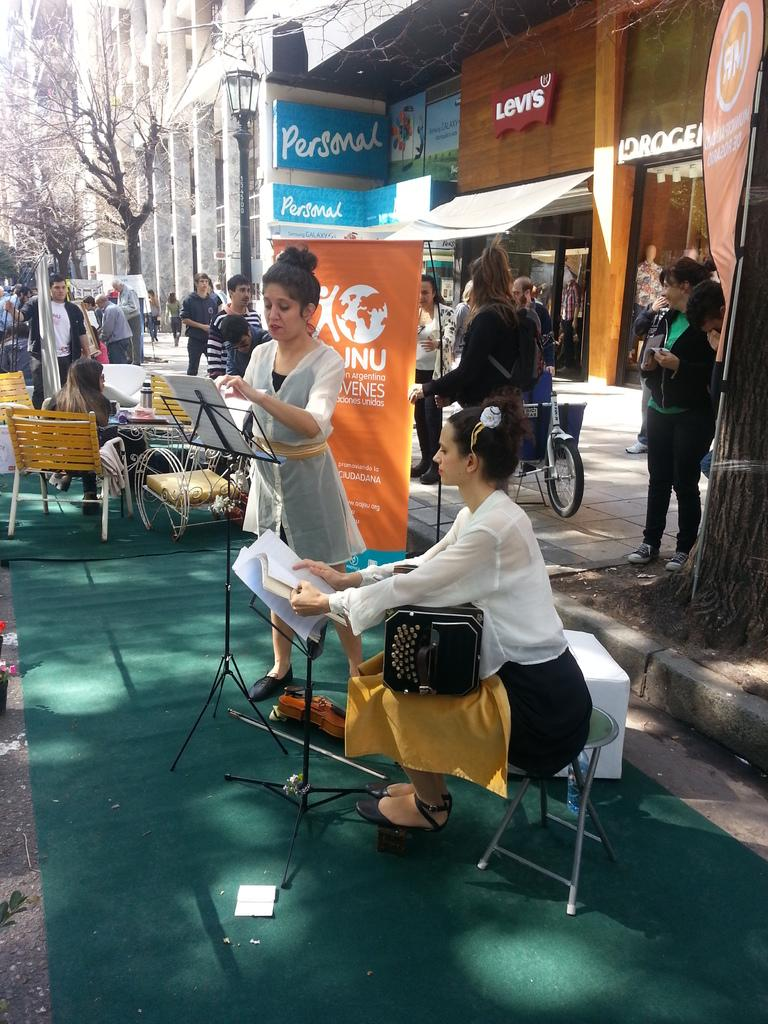Who or what can be seen in the image? There are people in the image. What type of natural elements are present in the image? There are trees in the image. What type of man-made structures are present in the image? There are buildings in the image. What is the grade of the protest in the image? There is no protest present in the image, so it is not possible to determine its grade. 